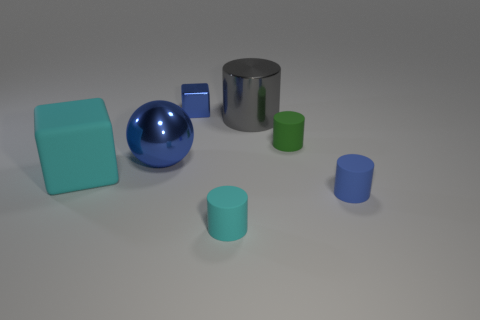Subtract all green rubber cylinders. How many cylinders are left? 3 Add 1 large gray shiny things. How many objects exist? 8 Subtract all blue cylinders. How many cylinders are left? 3 Subtract 2 cylinders. How many cylinders are left? 2 Subtract all red cubes. How many red spheres are left? 0 Subtract all tiny blue metal things. Subtract all small blue things. How many objects are left? 4 Add 6 large rubber objects. How many large rubber objects are left? 7 Add 1 big cyan objects. How many big cyan objects exist? 2 Subtract 0 purple balls. How many objects are left? 7 Subtract all blocks. How many objects are left? 5 